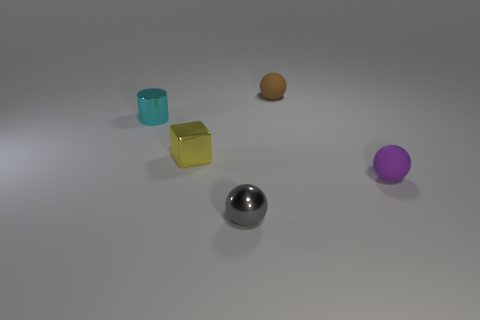Is there a tiny matte object of the same color as the metal cube?
Provide a short and direct response. No. Are there any brown rubber things?
Make the answer very short. Yes. What is the shape of the rubber object right of the tiny brown matte thing?
Offer a very short reply. Sphere. How many tiny objects are behind the small shiny sphere and left of the purple object?
Keep it short and to the point. 3. Is the shape of the rubber object in front of the tiny cyan cylinder the same as the small cyan metallic thing that is in front of the brown matte object?
Your answer should be compact. No. How many objects are green metallic objects or purple matte balls that are right of the small yellow cube?
Provide a succinct answer. 1. There is a small object that is both behind the small yellow cube and on the right side of the small metallic cylinder; what is its material?
Provide a succinct answer. Rubber. Is there any other thing that has the same shape as the small cyan object?
Your response must be concise. No. What is the color of the tiny ball that is the same material as the tiny brown thing?
Your response must be concise. Purple. What number of objects are either purple balls or purple shiny things?
Keep it short and to the point. 1. 